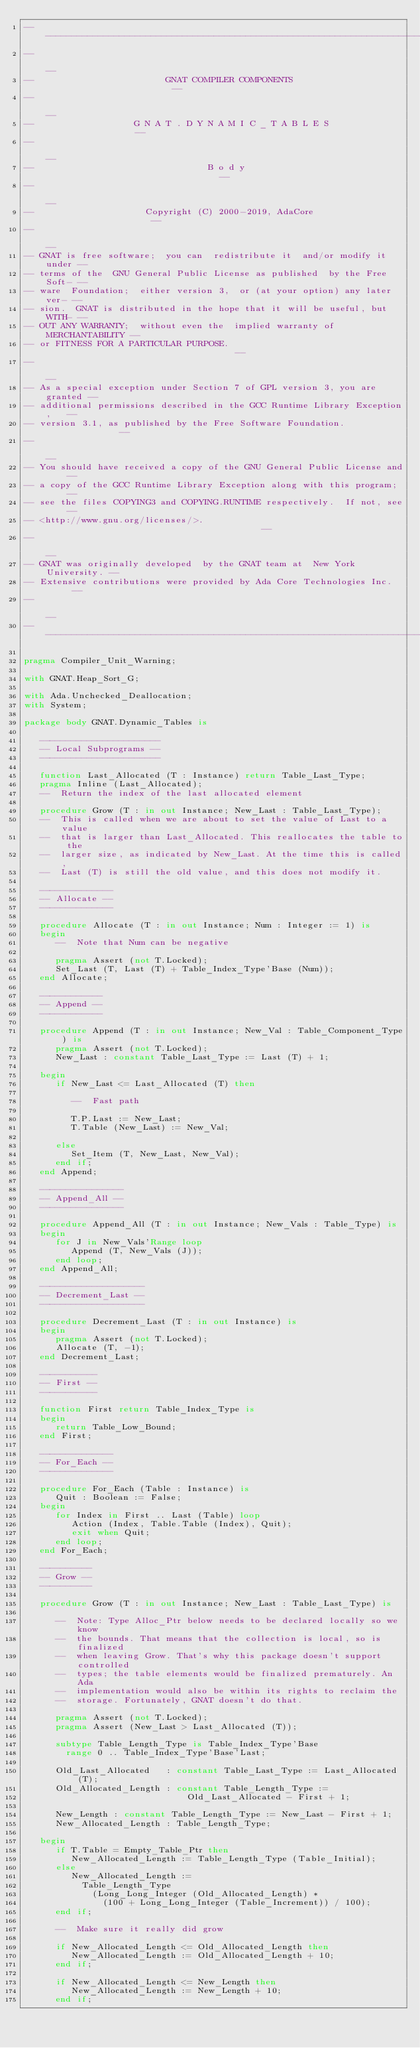Convert code to text. <code><loc_0><loc_0><loc_500><loc_500><_Ada_>------------------------------------------------------------------------------
--                                                                          --
--                         GNAT COMPILER COMPONENTS                         --
--                                                                          --
--                   G N A T . D Y N A M I C _ T A B L E S                  --
--                                                                          --
--                                 B o d y                                  --
--                                                                          --
--                     Copyright (C) 2000-2019, AdaCore                     --
--                                                                          --
-- GNAT is free software;  you can  redistribute it  and/or modify it under --
-- terms of the  GNU General Public License as published  by the Free Soft- --
-- ware  Foundation;  either version 3,  or (at your option) any later ver- --
-- sion.  GNAT is distributed in the hope that it will be useful, but WITH- --
-- OUT ANY WARRANTY;  without even the  implied warranty of MERCHANTABILITY --
-- or FITNESS FOR A PARTICULAR PURPOSE.                                     --
--                                                                          --
-- As a special exception under Section 7 of GPL version 3, you are granted --
-- additional permissions described in the GCC Runtime Library Exception,   --
-- version 3.1, as published by the Free Software Foundation.               --
--                                                                          --
-- You should have received a copy of the GNU General Public License and    --
-- a copy of the GCC Runtime Library Exception along with this program;     --
-- see the files COPYING3 and COPYING.RUNTIME respectively.  If not, see    --
-- <http://www.gnu.org/licenses/>.                                          --
--                                                                          --
-- GNAT was originally developed  by the GNAT team at  New York University. --
-- Extensive contributions were provided by Ada Core Technologies Inc.      --
--                                                                          --
------------------------------------------------------------------------------

pragma Compiler_Unit_Warning;

with GNAT.Heap_Sort_G;

with Ada.Unchecked_Deallocation;
with System;

package body GNAT.Dynamic_Tables is

   -----------------------
   -- Local Subprograms --
   -----------------------

   function Last_Allocated (T : Instance) return Table_Last_Type;
   pragma Inline (Last_Allocated);
   --  Return the index of the last allocated element

   procedure Grow (T : in out Instance; New_Last : Table_Last_Type);
   --  This is called when we are about to set the value of Last to a value
   --  that is larger than Last_Allocated. This reallocates the table to the
   --  larger size, as indicated by New_Last. At the time this is called,
   --  Last (T) is still the old value, and this does not modify it.

   --------------
   -- Allocate --
   --------------

   procedure Allocate (T : in out Instance; Num : Integer := 1) is
   begin
      --  Note that Num can be negative

      pragma Assert (not T.Locked);
      Set_Last (T, Last (T) + Table_Index_Type'Base (Num));
   end Allocate;

   ------------
   -- Append --
   ------------

   procedure Append (T : in out Instance; New_Val : Table_Component_Type) is
      pragma Assert (not T.Locked);
      New_Last : constant Table_Last_Type := Last (T) + 1;

   begin
      if New_Last <= Last_Allocated (T) then

         --  Fast path

         T.P.Last := New_Last;
         T.Table (New_Last) := New_Val;

      else
         Set_Item (T, New_Last, New_Val);
      end if;
   end Append;

   ----------------
   -- Append_All --
   ----------------

   procedure Append_All (T : in out Instance; New_Vals : Table_Type) is
   begin
      for J in New_Vals'Range loop
         Append (T, New_Vals (J));
      end loop;
   end Append_All;

   --------------------
   -- Decrement_Last --
   --------------------

   procedure Decrement_Last (T : in out Instance) is
   begin
      pragma Assert (not T.Locked);
      Allocate (T, -1);
   end Decrement_Last;

   -----------
   -- First --
   -----------

   function First return Table_Index_Type is
   begin
      return Table_Low_Bound;
   end First;

   --------------
   -- For_Each --
   --------------

   procedure For_Each (Table : Instance) is
      Quit : Boolean := False;
   begin
      for Index in First .. Last (Table) loop
         Action (Index, Table.Table (Index), Quit);
         exit when Quit;
      end loop;
   end For_Each;

   ----------
   -- Grow --
   ----------

   procedure Grow (T : in out Instance; New_Last : Table_Last_Type) is

      --  Note: Type Alloc_Ptr below needs to be declared locally so we know
      --  the bounds. That means that the collection is local, so is finalized
      --  when leaving Grow. That's why this package doesn't support controlled
      --  types; the table elements would be finalized prematurely. An Ada
      --  implementation would also be within its rights to reclaim the
      --  storage. Fortunately, GNAT doesn't do that.

      pragma Assert (not T.Locked);
      pragma Assert (New_Last > Last_Allocated (T));

      subtype Table_Length_Type is Table_Index_Type'Base
        range 0 .. Table_Index_Type'Base'Last;

      Old_Last_Allocated   : constant Table_Last_Type := Last_Allocated (T);
      Old_Allocated_Length : constant Table_Length_Type :=
                               Old_Last_Allocated - First + 1;

      New_Length : constant Table_Length_Type := New_Last - First + 1;
      New_Allocated_Length : Table_Length_Type;

   begin
      if T.Table = Empty_Table_Ptr then
         New_Allocated_Length := Table_Length_Type (Table_Initial);
      else
         New_Allocated_Length :=
           Table_Length_Type
             (Long_Long_Integer (Old_Allocated_Length) *
               (100 + Long_Long_Integer (Table_Increment)) / 100);
      end if;

      --  Make sure it really did grow

      if New_Allocated_Length <= Old_Allocated_Length then
         New_Allocated_Length := Old_Allocated_Length + 10;
      end if;

      if New_Allocated_Length <= New_Length then
         New_Allocated_Length := New_Length + 10;
      end if;
</code> 